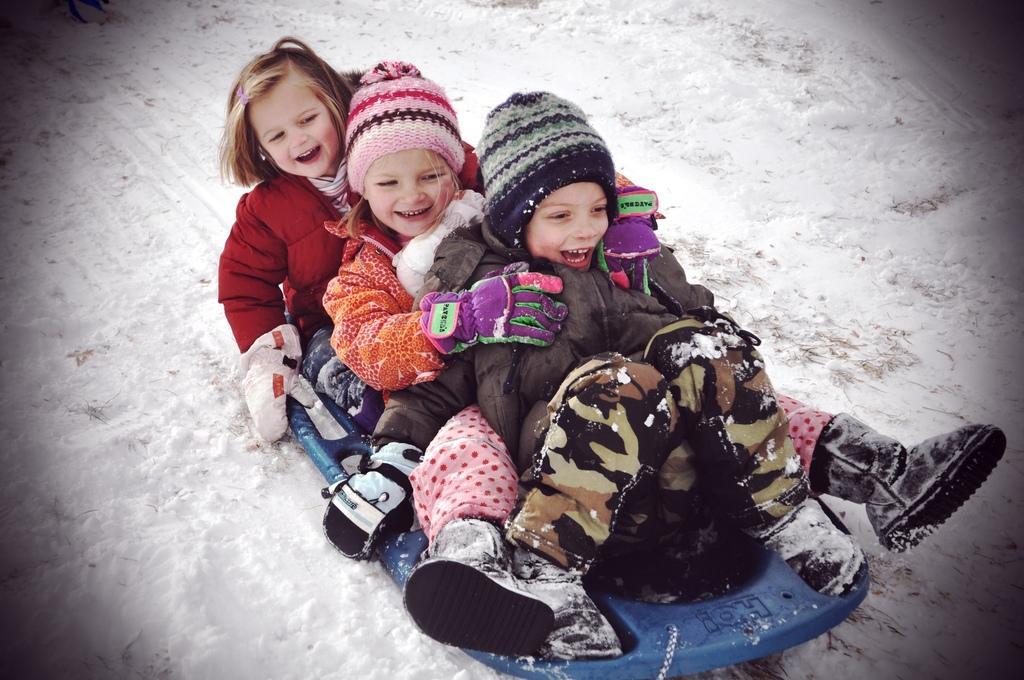Could you give a brief overview of what you see in this image? 3 Kids are playing in the snow, they wore coats, caps. This is the snow. 